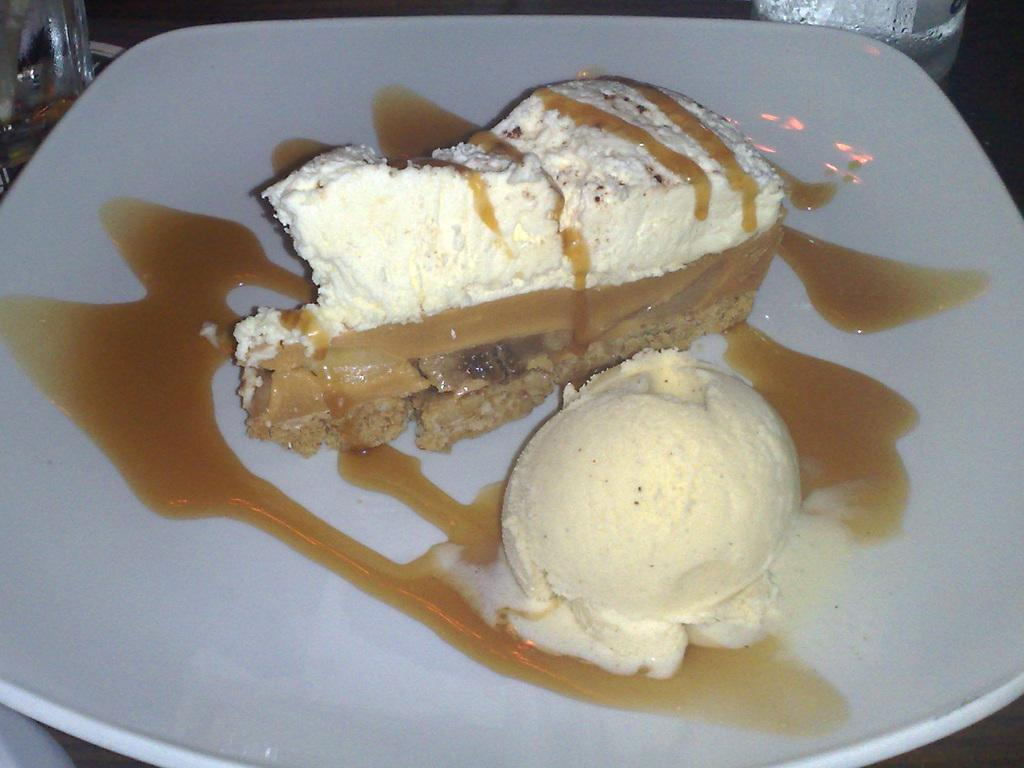What is on the white plate in the image? There is food on the white plate in the image. What else can be seen at the top of the image? There are glasses visible at the top of the image. What type of jewel is being used to support the food on the plate? There is no jewel present in the image; the food is simply on a white plate. 